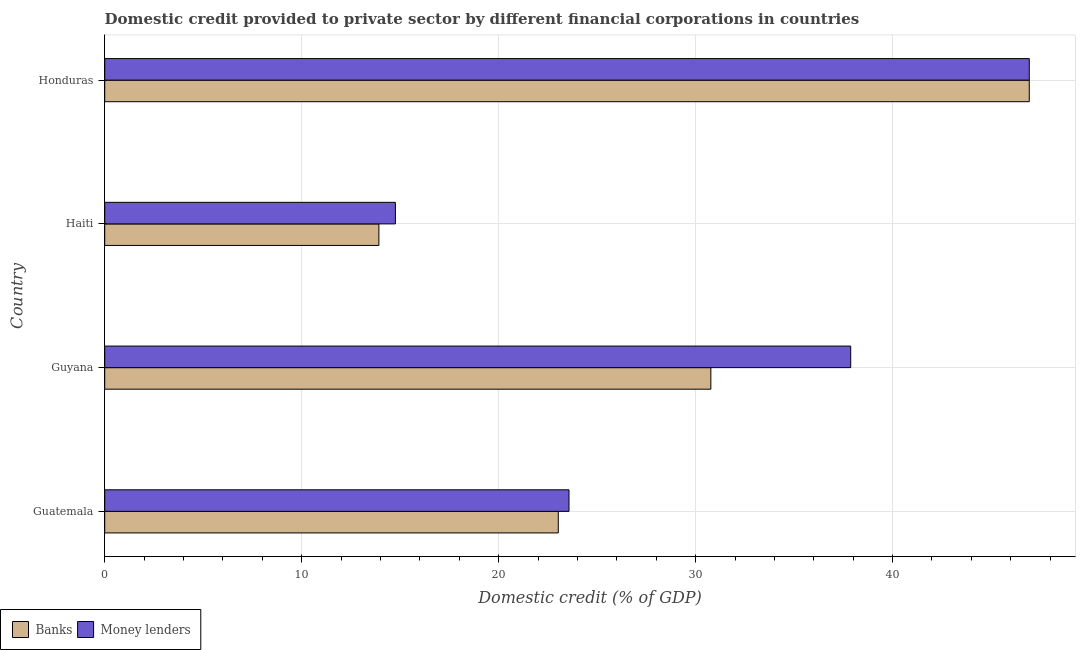How many different coloured bars are there?
Offer a very short reply. 2. How many groups of bars are there?
Your response must be concise. 4. What is the label of the 3rd group of bars from the top?
Your answer should be very brief. Guyana. What is the domestic credit provided by banks in Honduras?
Keep it short and to the point. 46.94. Across all countries, what is the maximum domestic credit provided by banks?
Provide a succinct answer. 46.94. Across all countries, what is the minimum domestic credit provided by money lenders?
Make the answer very short. 14.76. In which country was the domestic credit provided by money lenders maximum?
Your answer should be very brief. Honduras. In which country was the domestic credit provided by banks minimum?
Provide a short and direct response. Haiti. What is the total domestic credit provided by money lenders in the graph?
Your answer should be compact. 123.15. What is the difference between the domestic credit provided by banks in Guyana and that in Haiti?
Provide a succinct answer. 16.85. What is the difference between the domestic credit provided by banks in Guatemala and the domestic credit provided by money lenders in Haiti?
Ensure brevity in your answer.  8.27. What is the average domestic credit provided by banks per country?
Provide a short and direct response. 28.67. What is the difference between the domestic credit provided by money lenders and domestic credit provided by banks in Guatemala?
Give a very brief answer. 0.55. In how many countries, is the domestic credit provided by banks greater than 46 %?
Offer a very short reply. 1. What is the ratio of the domestic credit provided by money lenders in Guatemala to that in Guyana?
Your response must be concise. 0.62. Is the domestic credit provided by banks in Guyana less than that in Honduras?
Ensure brevity in your answer.  Yes. Is the difference between the domestic credit provided by money lenders in Guatemala and Honduras greater than the difference between the domestic credit provided by banks in Guatemala and Honduras?
Give a very brief answer. Yes. What is the difference between the highest and the second highest domestic credit provided by banks?
Your answer should be compact. 16.17. What is the difference between the highest and the lowest domestic credit provided by banks?
Provide a short and direct response. 33.02. Is the sum of the domestic credit provided by money lenders in Guatemala and Guyana greater than the maximum domestic credit provided by banks across all countries?
Offer a very short reply. Yes. What does the 1st bar from the top in Guatemala represents?
Ensure brevity in your answer.  Money lenders. What does the 2nd bar from the bottom in Guyana represents?
Provide a short and direct response. Money lenders. Are all the bars in the graph horizontal?
Offer a very short reply. Yes. Are the values on the major ticks of X-axis written in scientific E-notation?
Give a very brief answer. No. What is the title of the graph?
Your response must be concise. Domestic credit provided to private sector by different financial corporations in countries. Does "Revenue" appear as one of the legend labels in the graph?
Ensure brevity in your answer.  No. What is the label or title of the X-axis?
Your response must be concise. Domestic credit (% of GDP). What is the Domestic credit (% of GDP) in Banks in Guatemala?
Make the answer very short. 23.03. What is the Domestic credit (% of GDP) of Money lenders in Guatemala?
Provide a succinct answer. 23.57. What is the Domestic credit (% of GDP) of Banks in Guyana?
Provide a short and direct response. 30.77. What is the Domestic credit (% of GDP) of Money lenders in Guyana?
Your answer should be very brief. 37.88. What is the Domestic credit (% of GDP) of Banks in Haiti?
Offer a terse response. 13.92. What is the Domestic credit (% of GDP) in Money lenders in Haiti?
Make the answer very short. 14.76. What is the Domestic credit (% of GDP) in Banks in Honduras?
Your answer should be very brief. 46.94. What is the Domestic credit (% of GDP) of Money lenders in Honduras?
Ensure brevity in your answer.  46.94. Across all countries, what is the maximum Domestic credit (% of GDP) in Banks?
Give a very brief answer. 46.94. Across all countries, what is the maximum Domestic credit (% of GDP) in Money lenders?
Offer a terse response. 46.94. Across all countries, what is the minimum Domestic credit (% of GDP) of Banks?
Provide a succinct answer. 13.92. Across all countries, what is the minimum Domestic credit (% of GDP) of Money lenders?
Offer a terse response. 14.76. What is the total Domestic credit (% of GDP) in Banks in the graph?
Provide a short and direct response. 114.66. What is the total Domestic credit (% of GDP) of Money lenders in the graph?
Make the answer very short. 123.15. What is the difference between the Domestic credit (% of GDP) of Banks in Guatemala and that in Guyana?
Provide a succinct answer. -7.75. What is the difference between the Domestic credit (% of GDP) in Money lenders in Guatemala and that in Guyana?
Make the answer very short. -14.3. What is the difference between the Domestic credit (% of GDP) of Banks in Guatemala and that in Haiti?
Offer a terse response. 9.11. What is the difference between the Domestic credit (% of GDP) in Money lenders in Guatemala and that in Haiti?
Your response must be concise. 8.81. What is the difference between the Domestic credit (% of GDP) of Banks in Guatemala and that in Honduras?
Keep it short and to the point. -23.91. What is the difference between the Domestic credit (% of GDP) of Money lenders in Guatemala and that in Honduras?
Offer a terse response. -23.37. What is the difference between the Domestic credit (% of GDP) in Banks in Guyana and that in Haiti?
Offer a terse response. 16.85. What is the difference between the Domestic credit (% of GDP) in Money lenders in Guyana and that in Haiti?
Offer a very short reply. 23.12. What is the difference between the Domestic credit (% of GDP) in Banks in Guyana and that in Honduras?
Give a very brief answer. -16.17. What is the difference between the Domestic credit (% of GDP) of Money lenders in Guyana and that in Honduras?
Give a very brief answer. -9.06. What is the difference between the Domestic credit (% of GDP) in Banks in Haiti and that in Honduras?
Your answer should be compact. -33.02. What is the difference between the Domestic credit (% of GDP) in Money lenders in Haiti and that in Honduras?
Make the answer very short. -32.18. What is the difference between the Domestic credit (% of GDP) in Banks in Guatemala and the Domestic credit (% of GDP) in Money lenders in Guyana?
Make the answer very short. -14.85. What is the difference between the Domestic credit (% of GDP) of Banks in Guatemala and the Domestic credit (% of GDP) of Money lenders in Haiti?
Give a very brief answer. 8.27. What is the difference between the Domestic credit (% of GDP) in Banks in Guatemala and the Domestic credit (% of GDP) in Money lenders in Honduras?
Provide a succinct answer. -23.91. What is the difference between the Domestic credit (% of GDP) in Banks in Guyana and the Domestic credit (% of GDP) in Money lenders in Haiti?
Offer a very short reply. 16.02. What is the difference between the Domestic credit (% of GDP) of Banks in Guyana and the Domestic credit (% of GDP) of Money lenders in Honduras?
Give a very brief answer. -16.17. What is the difference between the Domestic credit (% of GDP) of Banks in Haiti and the Domestic credit (% of GDP) of Money lenders in Honduras?
Make the answer very short. -33.02. What is the average Domestic credit (% of GDP) in Banks per country?
Provide a succinct answer. 28.67. What is the average Domestic credit (% of GDP) of Money lenders per country?
Offer a terse response. 30.79. What is the difference between the Domestic credit (% of GDP) of Banks and Domestic credit (% of GDP) of Money lenders in Guatemala?
Make the answer very short. -0.54. What is the difference between the Domestic credit (% of GDP) of Banks and Domestic credit (% of GDP) of Money lenders in Guyana?
Your response must be concise. -7.1. What is the difference between the Domestic credit (% of GDP) in Banks and Domestic credit (% of GDP) in Money lenders in Haiti?
Keep it short and to the point. -0.84. What is the ratio of the Domestic credit (% of GDP) in Banks in Guatemala to that in Guyana?
Provide a short and direct response. 0.75. What is the ratio of the Domestic credit (% of GDP) of Money lenders in Guatemala to that in Guyana?
Make the answer very short. 0.62. What is the ratio of the Domestic credit (% of GDP) in Banks in Guatemala to that in Haiti?
Your answer should be compact. 1.65. What is the ratio of the Domestic credit (% of GDP) of Money lenders in Guatemala to that in Haiti?
Provide a succinct answer. 1.6. What is the ratio of the Domestic credit (% of GDP) of Banks in Guatemala to that in Honduras?
Ensure brevity in your answer.  0.49. What is the ratio of the Domestic credit (% of GDP) in Money lenders in Guatemala to that in Honduras?
Your response must be concise. 0.5. What is the ratio of the Domestic credit (% of GDP) in Banks in Guyana to that in Haiti?
Keep it short and to the point. 2.21. What is the ratio of the Domestic credit (% of GDP) in Money lenders in Guyana to that in Haiti?
Keep it short and to the point. 2.57. What is the ratio of the Domestic credit (% of GDP) in Banks in Guyana to that in Honduras?
Keep it short and to the point. 0.66. What is the ratio of the Domestic credit (% of GDP) in Money lenders in Guyana to that in Honduras?
Keep it short and to the point. 0.81. What is the ratio of the Domestic credit (% of GDP) of Banks in Haiti to that in Honduras?
Give a very brief answer. 0.3. What is the ratio of the Domestic credit (% of GDP) in Money lenders in Haiti to that in Honduras?
Offer a terse response. 0.31. What is the difference between the highest and the second highest Domestic credit (% of GDP) in Banks?
Your response must be concise. 16.17. What is the difference between the highest and the second highest Domestic credit (% of GDP) in Money lenders?
Offer a very short reply. 9.06. What is the difference between the highest and the lowest Domestic credit (% of GDP) of Banks?
Give a very brief answer. 33.02. What is the difference between the highest and the lowest Domestic credit (% of GDP) in Money lenders?
Give a very brief answer. 32.18. 